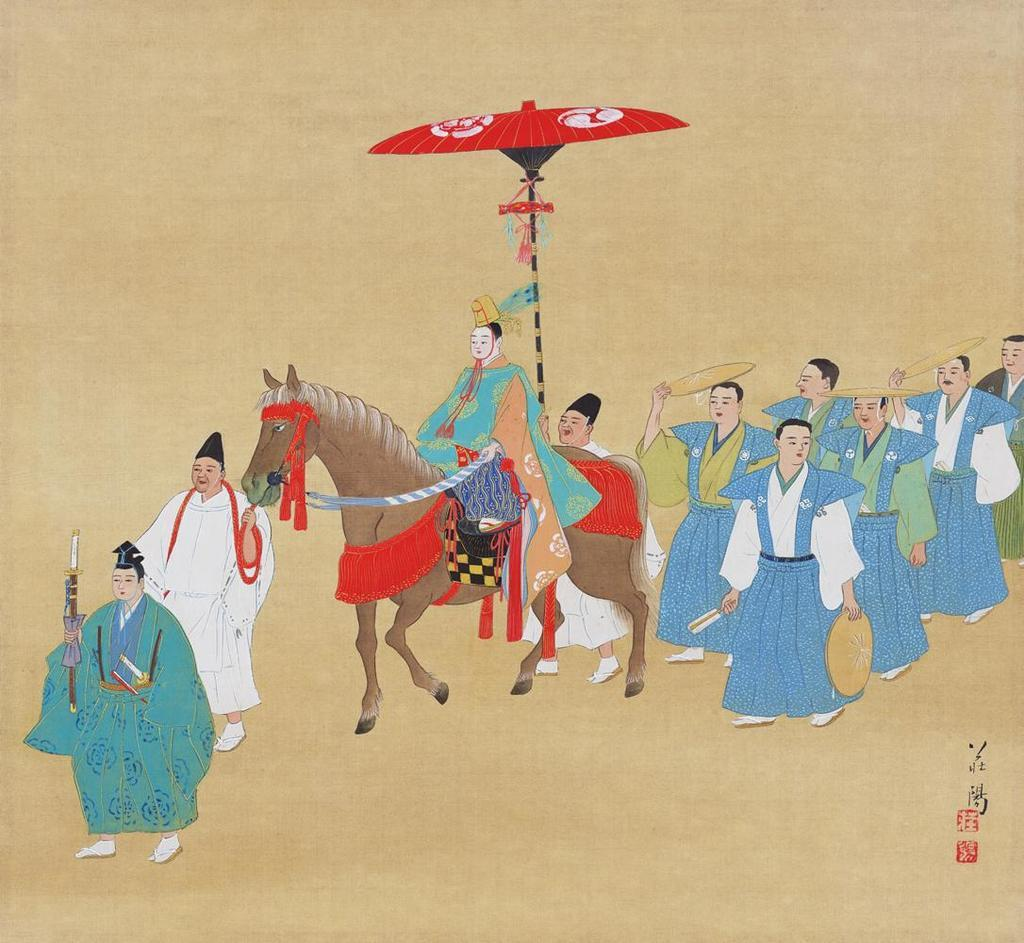What style is the image drawn in? The image is a cartoon. What are the people in the center of the image doing? The people are walking in the center of the image. What are the people holding? The people are holding objects. Can you describe the person in the image who is not walking? There is a person sitting on a horse in the image. What is the writer's name in the image? There is no writer present in the image. How many acres of land does the aunt own in the image? There is no mention of an aunt or land in the image. 